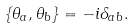Convert formula to latex. <formula><loc_0><loc_0><loc_500><loc_500>\{ \theta _ { a } , \theta _ { b } \} = - i \delta _ { a b } .</formula> 